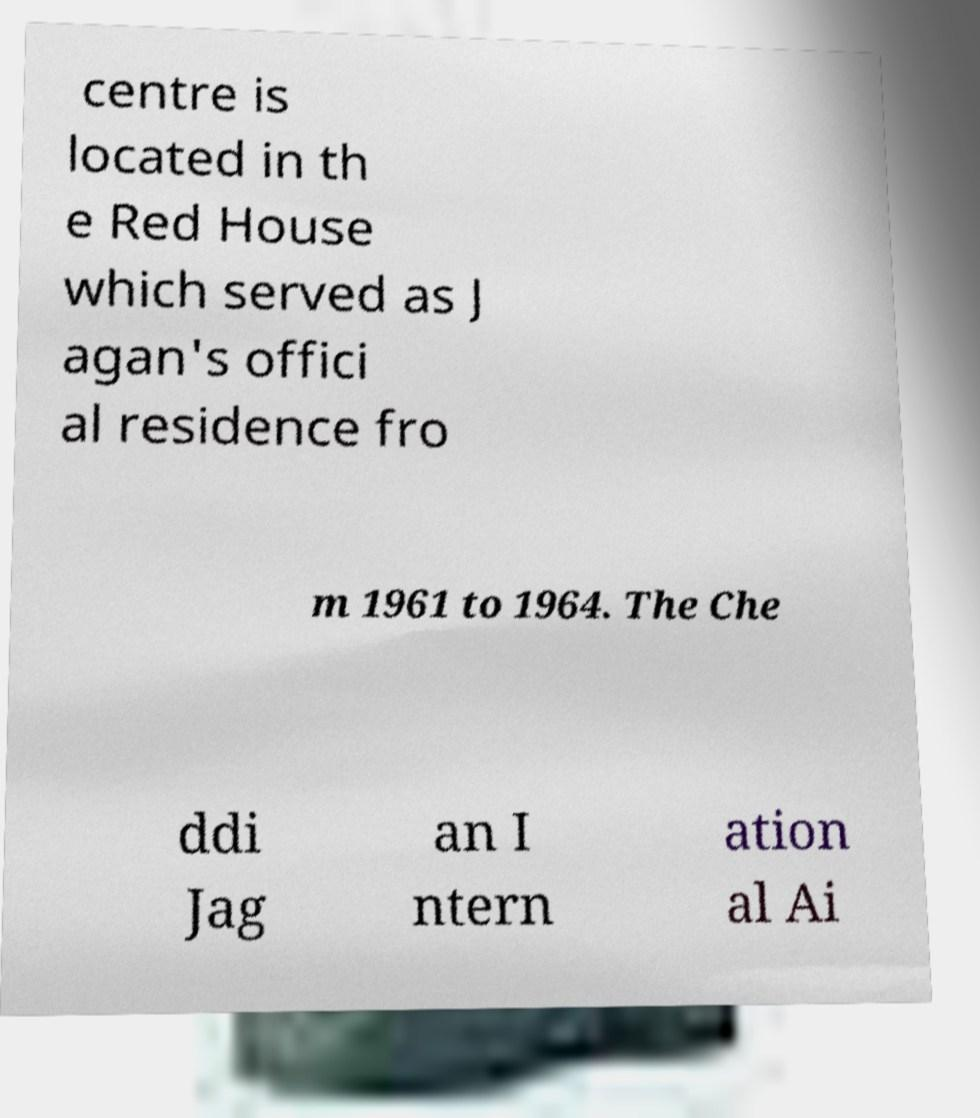Can you read and provide the text displayed in the image?This photo seems to have some interesting text. Can you extract and type it out for me? centre is located in th e Red House which served as J agan's offici al residence fro m 1961 to 1964. The Che ddi Jag an I ntern ation al Ai 